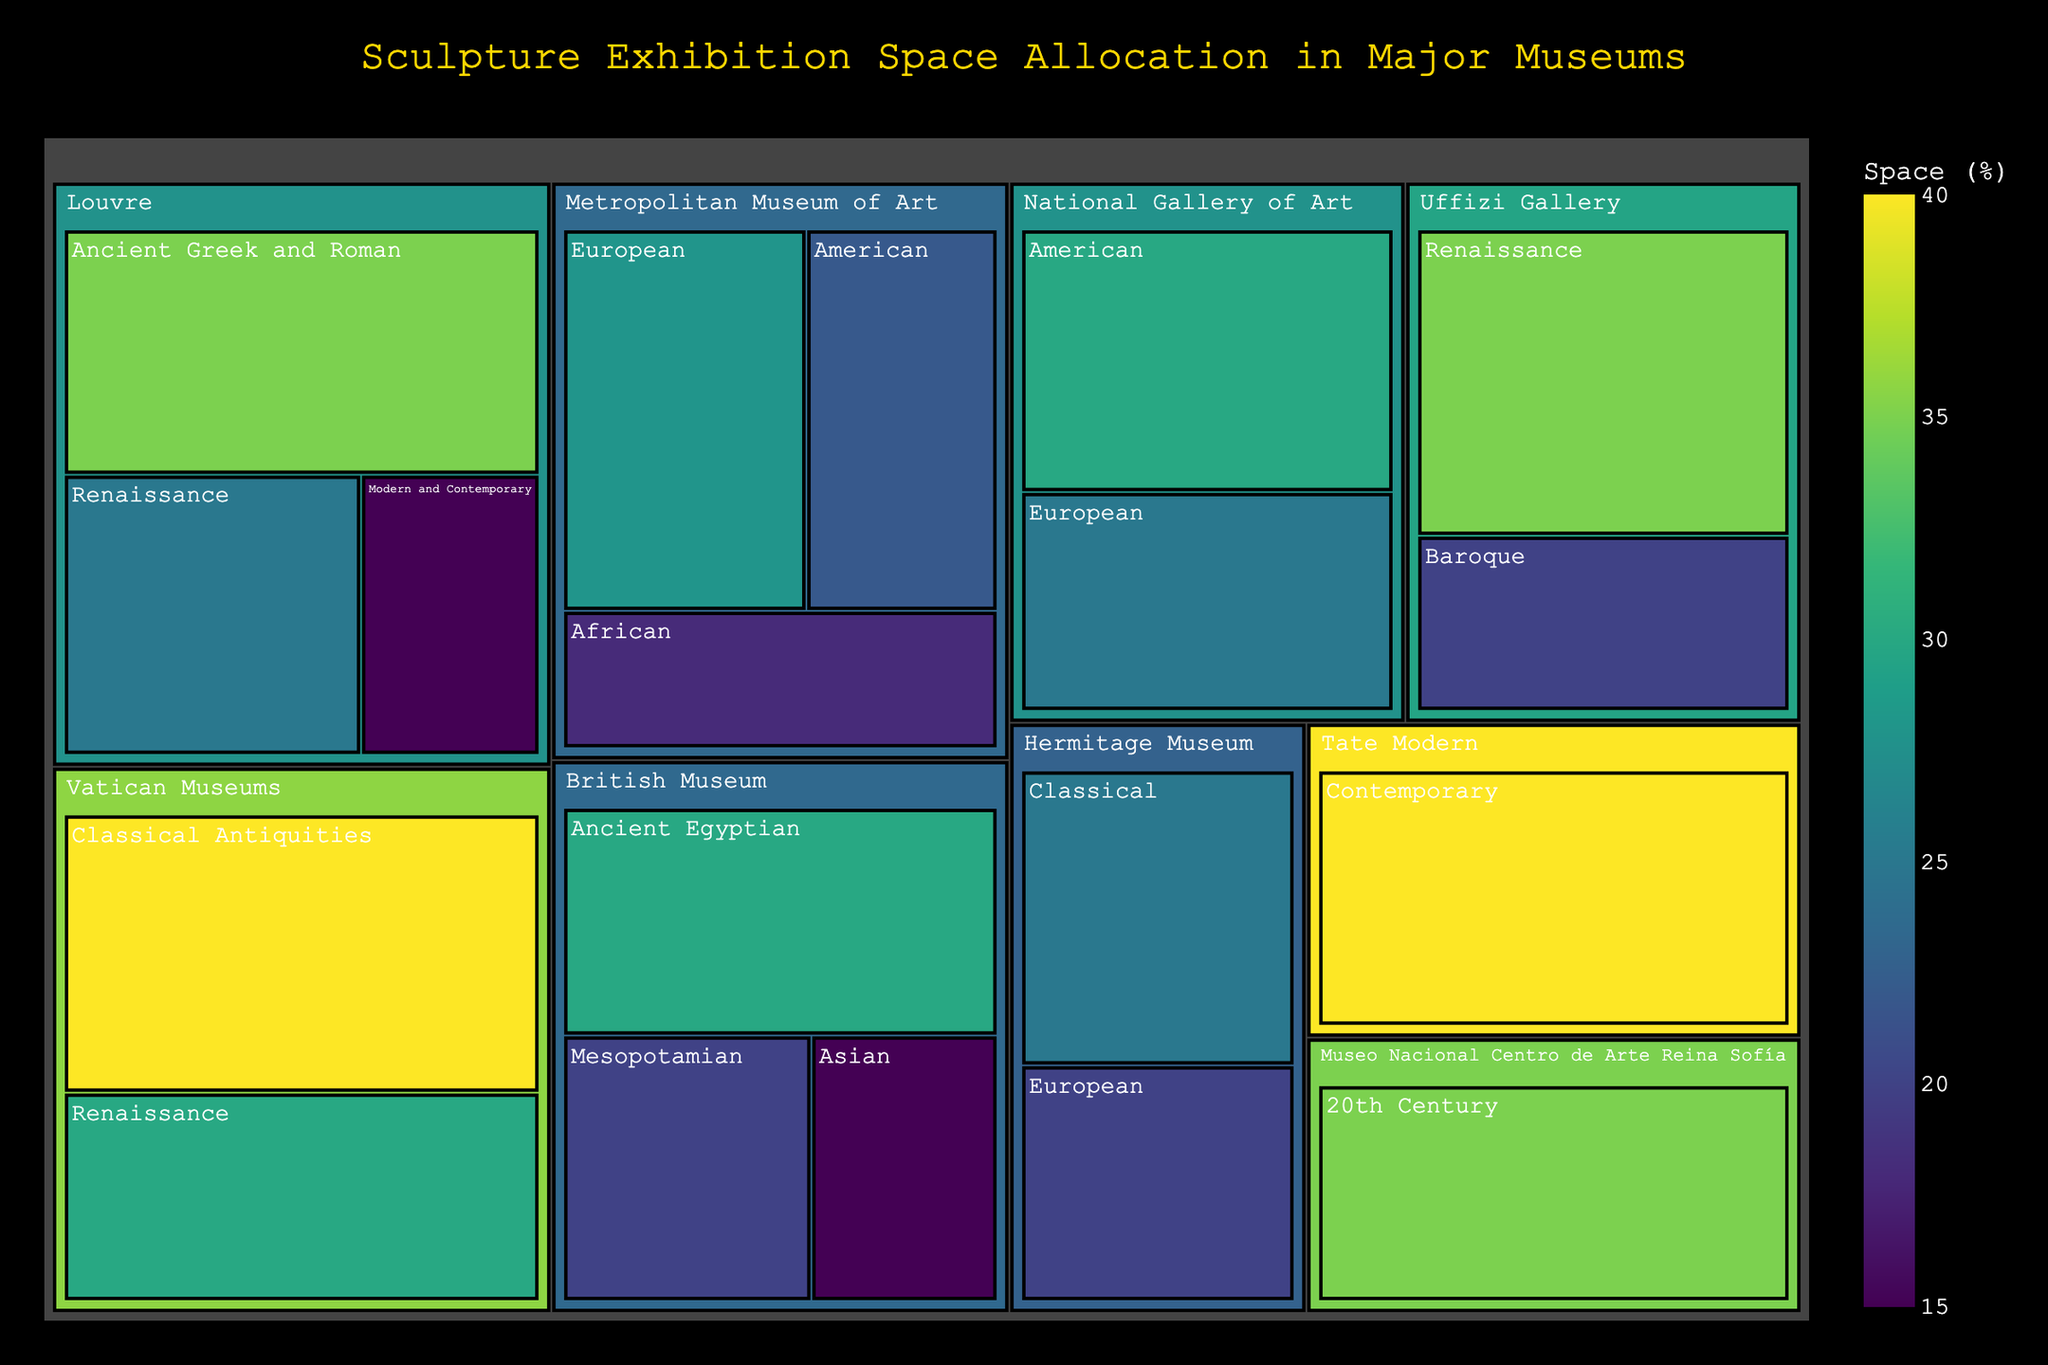What's the title of the Treemap? The title is displayed prominently at the top of the Treemap and it provides an overview of what the chart represents. The title helps viewers immediately understand the context of the data presented.
Answer: Sculpture Exhibition Space Allocation in Major Museums Which museum has the largest space allocation for Renaissance sculptures? By looking at the size of the blocks within the categories, we can observe that the museum with the largest space allocated to Renaissance sculptures is identified by the largest block within the Renaissance subcategory.
Answer: Louvre What percentage of space is allocated to Ancient Greek and Roman sculptures in the Louvre? Locate the block for Ancient Greek and Roman sculptures within the Louvre category. The value shown indicates the percentage of space allocated to it.
Answer: 35% How does the space allocation for European sculptures compare between the Metropolitan Museum of Art and the Hermitage Museum? Compare the sizes of the blocks labeled 'European' under both the Metropolitan Museum of Art and the Hermitage Museum categories. The numbers within these blocks provide the percentage space allocated, allowing for direct comparison.
Answer: 28% (Metropolitan Museum of Art) vs 20% (Hermitage Museum) Which subcategory has the highest space allocation in the British Museum? Identify the largest block under the British Museum category. The largest block signifies the subcategory with the highest space allocation.
Answer: Ancient Egyptian What is the combined space allocation for Renaissance sculptures at the Vatican Museums and Uffizi Gallery? Add the space allocation percentages for Renaissance sculptures from both the Vatican Museums and Uffizi Gallery. These values are 30% for the Vatican Museums and 35% for Uffizi Gallery.
Answer: 65% How does the space allocation for American sculptures compare between the Metropolitan Museum of Art and the National Gallery of Art? Compare the American sculpture blocks in both museums. The Metropolitan Museum of Art has 22% while the National Gallery of Art has 30% allocated.
Answer: The National Gallery of Art allocates more space (30%) compared to the Metropolitan Museum of Art (22%) What is the color indicating the space allocation for the largest category? The largest category is easy to identify by the size of its block. The color of the block can be matched with the color scale bar to find its corresponding space allocation value.
Answer: Deep green indicates large space allocation How many museums allocate space to Ancient cultures (e.g., Greek, Roman, Egyptian, Mesopotamian)? Determine the museums involved in allocating space to ancient cultures by identifying the corresponding subcategories in each museum's section.
Answer: Four (Louvre, British Museum, Vatican Museums, Hermitage Museum) What is the smallest subcategory for sculpture space allocation in the Treemap? Identify the smallest block in the Treemap across all categories. The smallest block signifies the subcategory with the least space allocated.
Answer: Uffizi Gallery - Baroque 